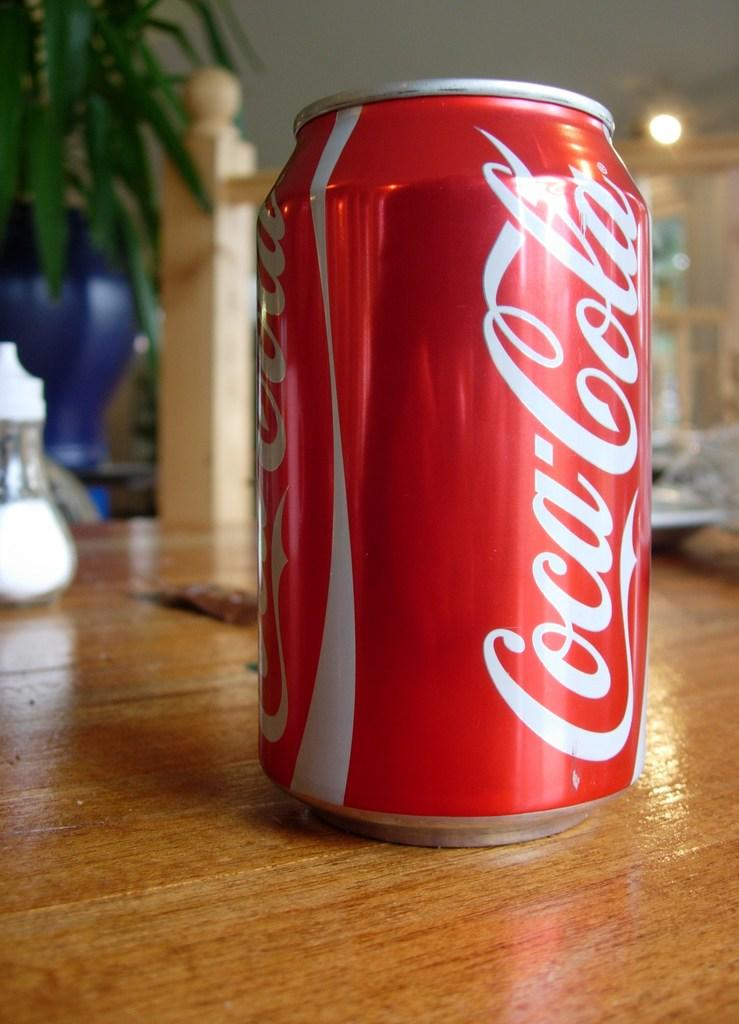<image>
Present a compact description of the photo's key features. A red and white can of coca cola branded soda is sitting on a wooden table. 